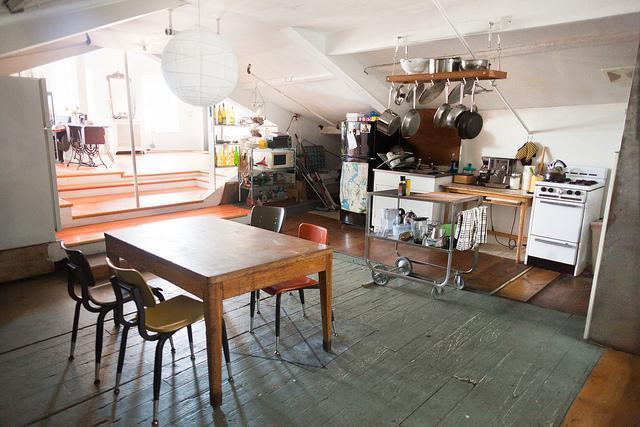How many chairs are there?
Give a very brief answer. 4. How many chairs do you see?
Give a very brief answer. 4. How many chairs are visible?
Give a very brief answer. 3. How many zebras are there?
Give a very brief answer. 0. 